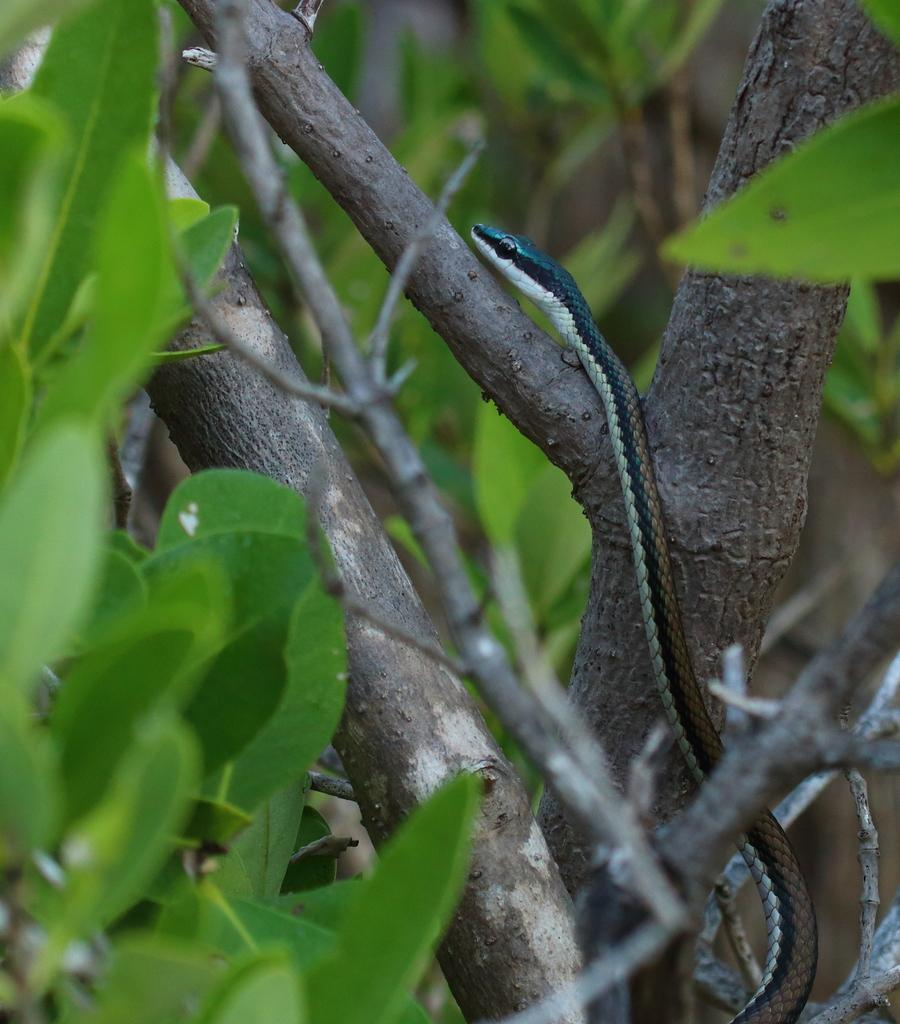What animal is present in the image? There is a snake in the image. Where is the snake located? The snake is on a tree. What is the color of the snake? The snake is brown in color. What type of vegetation can be seen on the left side of the image? There are green leaves on the left side of the image. What type of produce is hanging from the tree in the image? There is no produce present in the image; it features a brown snake on a tree. How many rabbits can be seen playing with a kite in the image? There are no rabbits or kites present in the image. 